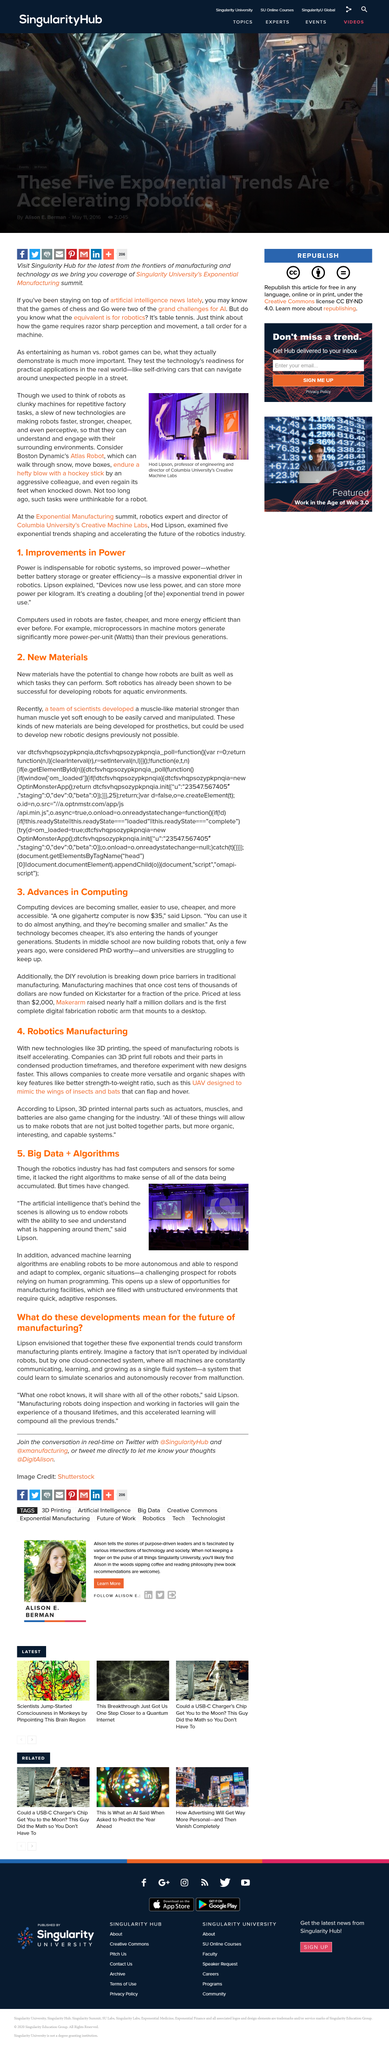Indicate a few pertinent items in this graphic. The rapid speed of manufacturing robots has increased dramatically due to the invention of 3D printing technology. The article asserts that computers, which are now faster, cheaper, and more energy efficient than ever before, are increasingly being used in robots. The robotics industry was unable to make sense of the vast amounts of data it was collecting with its fast computers and sensors due to the lack of appropriate algorithms. It is confirmed that Boston Dynamic's Atlas robot is capable of walking through snow with ease. The use of advancements in computing has led to a significant decrease in their cost and the rise of DIY revolutions has further reduced the price of manufacturing machines. This development has been made possible through the use of platforms like Kickstarter, which have made it possible to produce machines at a fraction of their previous, more expensive cost. 